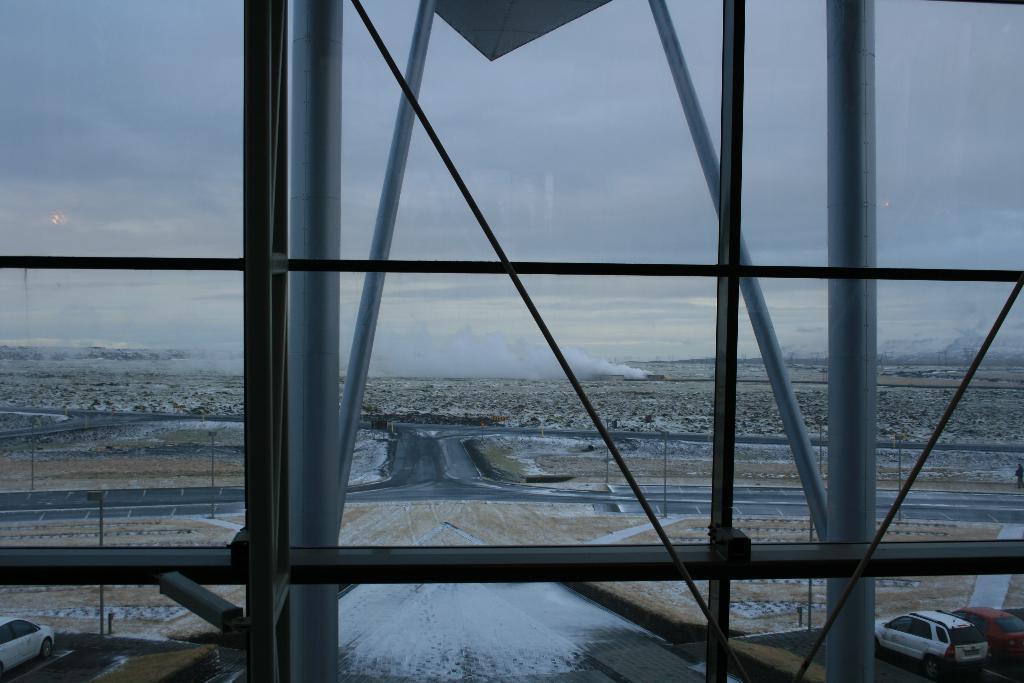Could you give a brief overview of what you see in this image? In this picture I can observe road in the middle of the picture. I can observe metal rods in this picture. In the background I can observe clouds in the sky. 